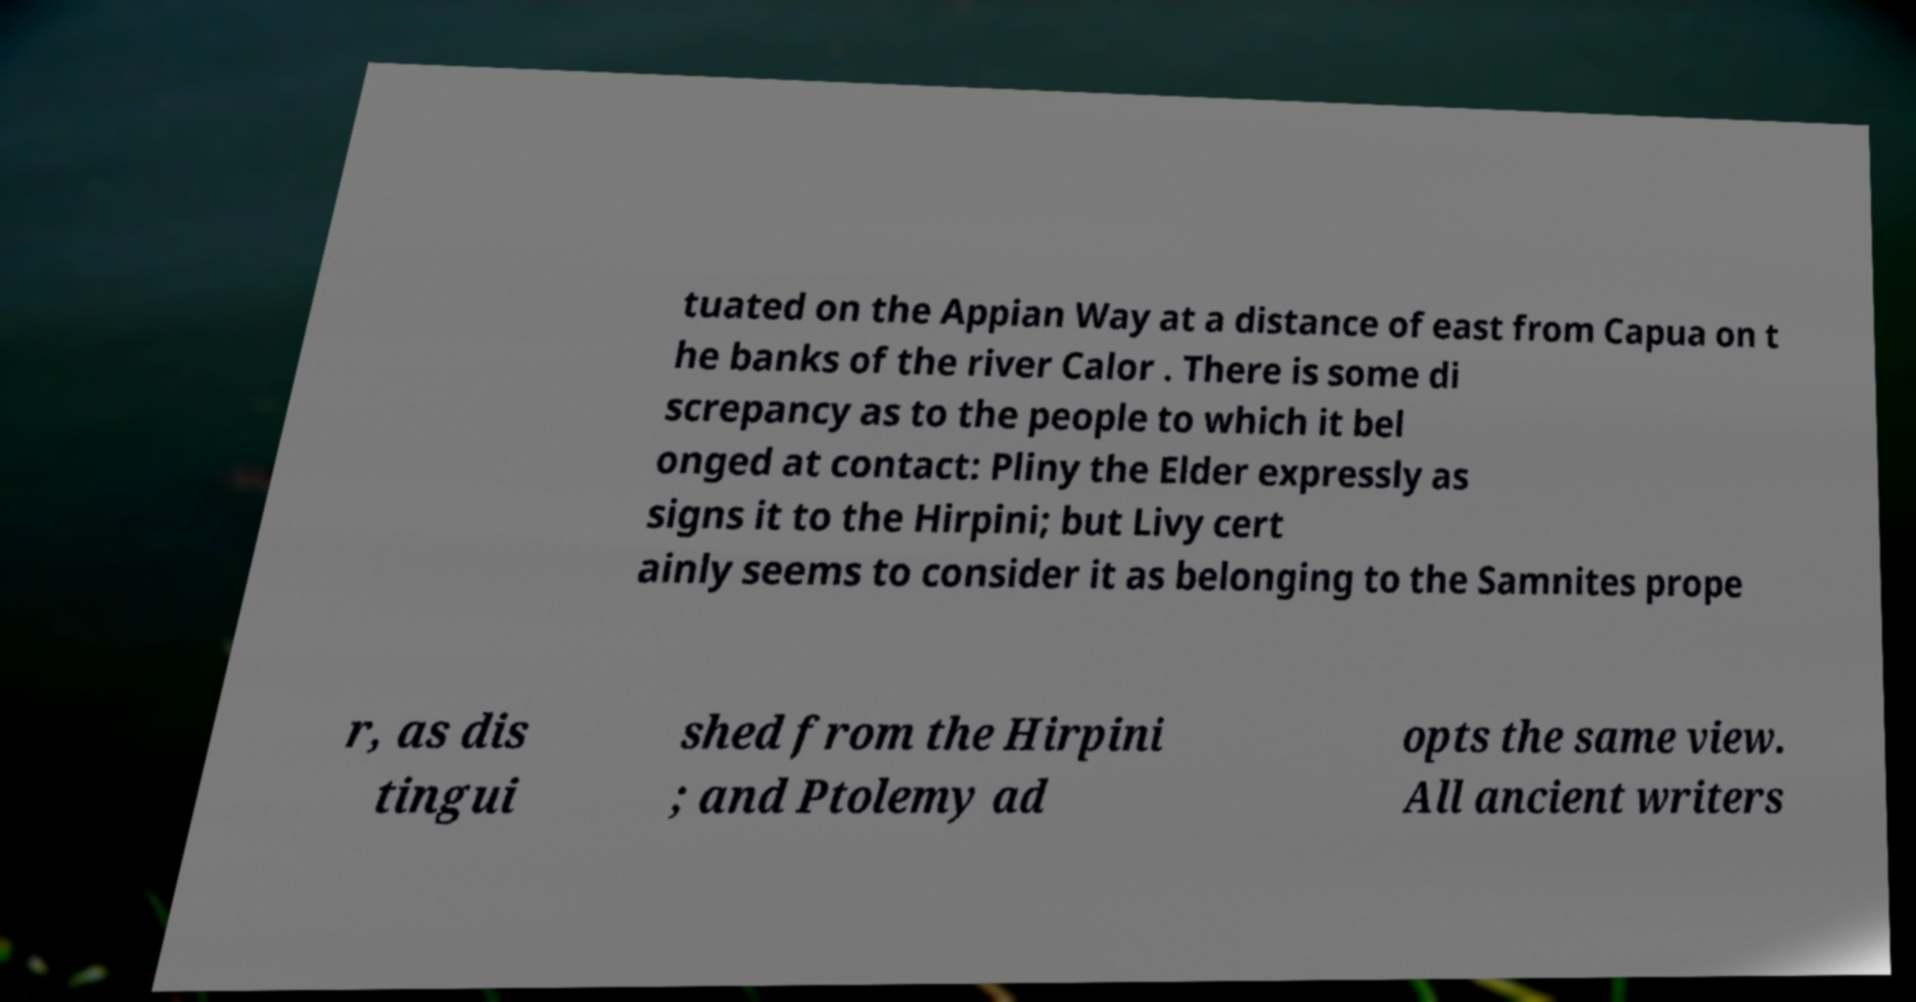Could you extract and type out the text from this image? tuated on the Appian Way at a distance of east from Capua on t he banks of the river Calor . There is some di screpancy as to the people to which it bel onged at contact: Pliny the Elder expressly as signs it to the Hirpini; but Livy cert ainly seems to consider it as belonging to the Samnites prope r, as dis tingui shed from the Hirpini ; and Ptolemy ad opts the same view. All ancient writers 